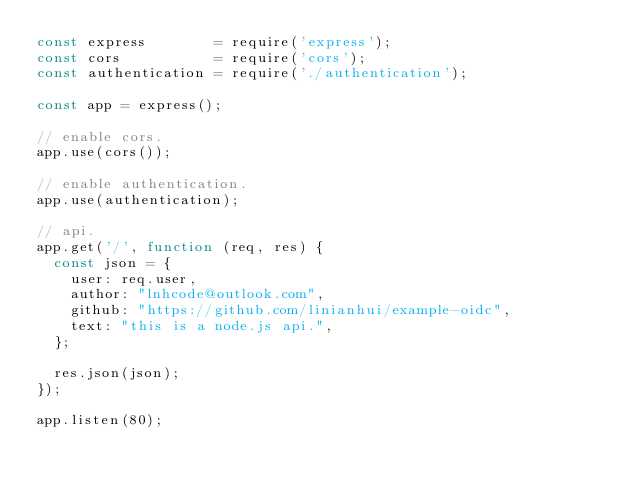Convert code to text. <code><loc_0><loc_0><loc_500><loc_500><_JavaScript_>const express        = require('express');
const cors           = require('cors');
const authentication = require('./authentication');

const app = express();

// enable cors.
app.use(cors());

// enable authentication.
app.use(authentication);

// api.
app.get('/', function (req, res) {
  const json = {
    user: req.user,
    author: "lnhcode@outlook.com",
    github: "https://github.com/linianhui/example-oidc",
    text: "this is a node.js api.",
  };

  res.json(json);
});

app.listen(80);
</code> 